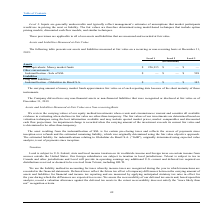According to Loral Space Communications's financial document, What is the usefulness of the carrying amount of money market funds? approximates fair value as of each reporting date. The document states: "The carrying amount of money market funds approximates fair value as of each reporting date because of the short maturity of those..." Also, What are the fair value of the company's respective non-financial assets and liabilities recognised or disclosed as of December 31, 2019? The document shows two values: 0 and 0 (in thousands). From the document: "2019:..." Also, What are the company's Level 2 and 3 long term liabilities as at December 31, 2019? The document shows two values: 0 and $145 (in thousands). From the document: "mnification - Globalstar do Brasil S.A. $ — $ — $ 145 2019:..." Also, can you calculate: What is the company's net assets measured at fair value as at December 31, 2019? Based on the calculation: $256,915 + $598 - $145 , the result is 257368 (in thousands). This is based on the information: "Indemnification - Sale of SSL $ — $ — $ 598 mnification - Globalstar do Brasil S.A. $ — $ — $ 145 Cash equivalents: Money market funds $ 256,915 $ — $ —..." The key data points involved are: 145, 256,915, 598. Also, can you calculate: What is the fair value of the company's total assets as at December 31, 2019? Based on the calculation: $256,915 + $598 , the result is 257513 (in thousands). This is based on the information: "Indemnification - Sale of SSL $ — $ — $ 598 Cash equivalents: Money market funds $ 256,915 $ — $ —..." The key data points involved are: 256,915, 598. Also, can you calculate: What is the total fair value of the company's Level 3 net assets? Based on the calculation: $598 - $145 , the result is 453 (in thousands). This is based on the information: "mnification - Globalstar do Brasil S.A. $ — $ — $ 145 Indemnification - Sale of SSL $ — $ — $ 598..." The key data points involved are: 145, 598. 